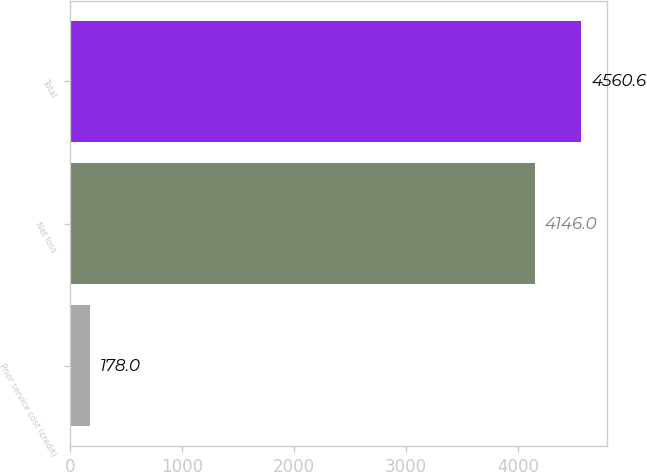Convert chart to OTSL. <chart><loc_0><loc_0><loc_500><loc_500><bar_chart><fcel>Prior service cost (credit)<fcel>Net loss<fcel>Total<nl><fcel>178<fcel>4146<fcel>4560.6<nl></chart> 